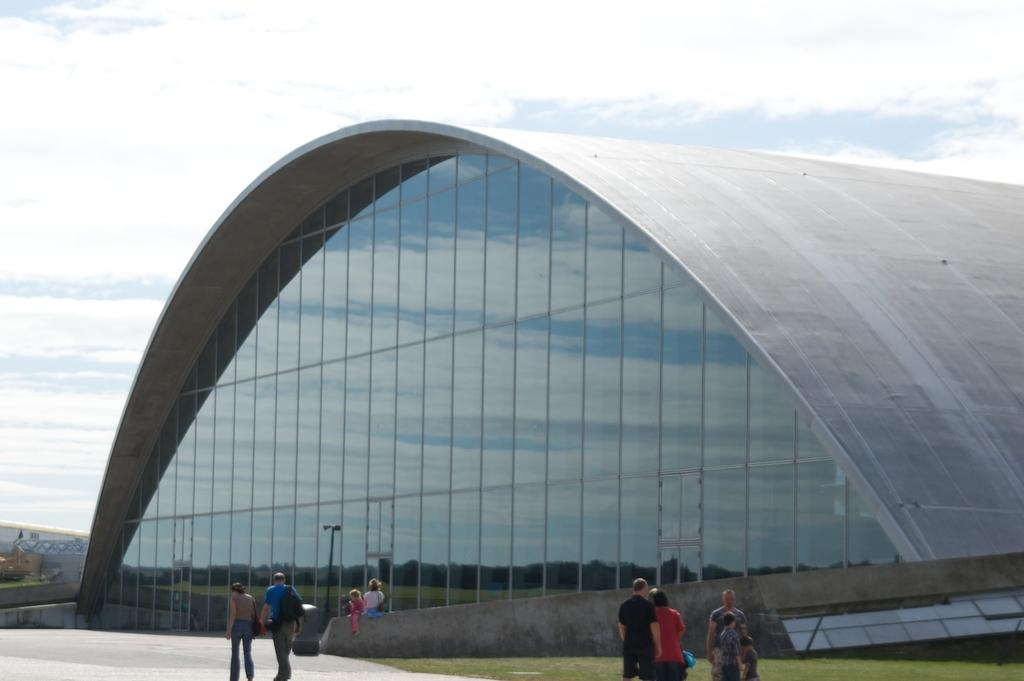What type of surface is visible in the image? There is ground visible in the image. What are the persons in the image doing? There are persons standing on the ground in the image. What type of vegetation is present in the image? There is grass in the image. What type of structures can be seen in the image? There are huge buildings in the image. What is visible in the background of the image? The sky is visible in the background of the image. Can you tell me how many tramps are resting on the grass in the image? There are no tramps present in the image, and therefore no such activity can be observed. 